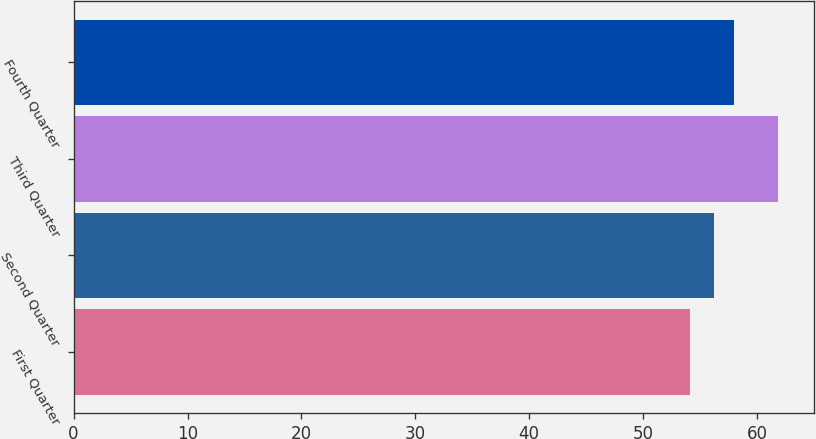Convert chart. <chart><loc_0><loc_0><loc_500><loc_500><bar_chart><fcel>First Quarter<fcel>Second Quarter<fcel>Third Quarter<fcel>Fourth Quarter<nl><fcel>54.1<fcel>56.23<fcel>61.87<fcel>57.96<nl></chart> 